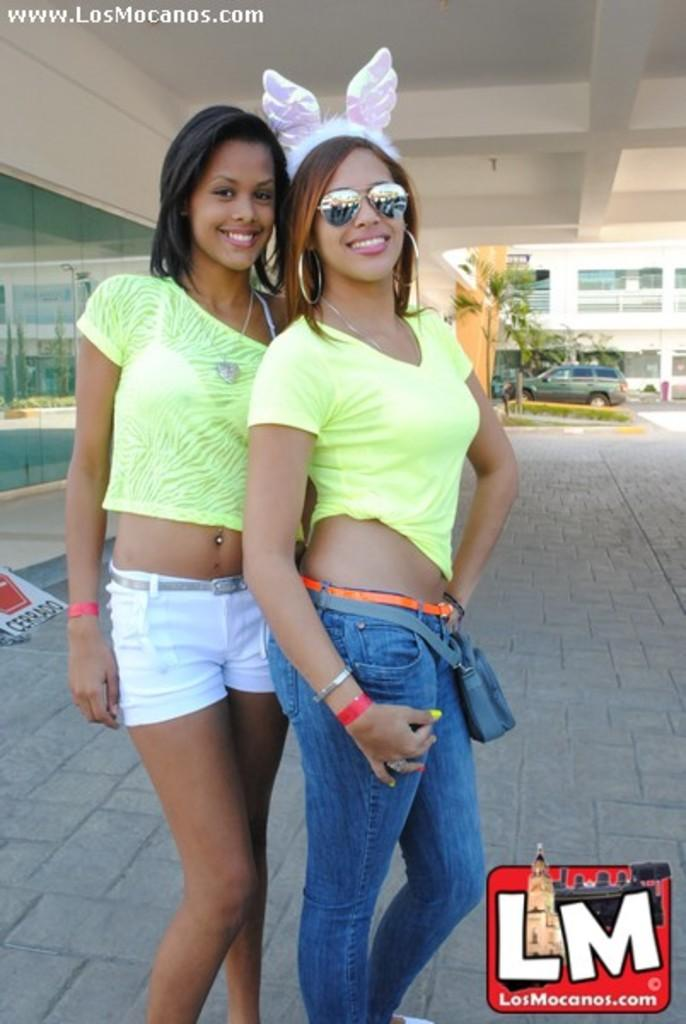How many people are in the image? There are two people in the image. What colors are the dresses of the people in the image? The people are wearing yellow, white, and blue dresses. What can be seen in the background of the image? There is a vehicle, plants, and buildings visible in the background of the image. What type of seed is being planted by the person in the image? There is no person planting a seed in the image; the people are wearing dresses and there are no gardening activities depicted. 